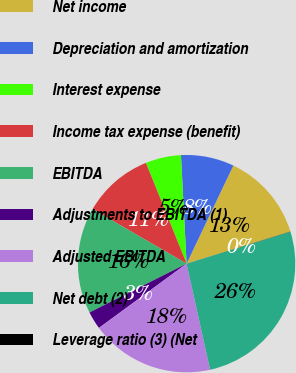Convert chart. <chart><loc_0><loc_0><loc_500><loc_500><pie_chart><fcel>Net income<fcel>Depreciation and amortization<fcel>Interest expense<fcel>Income tax expense (benefit)<fcel>EBITDA<fcel>Adjustments to EBITDA (1)<fcel>Adjusted EBITDA<fcel>Net debt (2)<fcel>Leverage ratio (3) (Net<nl><fcel>13.15%<fcel>7.9%<fcel>5.28%<fcel>10.53%<fcel>15.78%<fcel>2.66%<fcel>18.4%<fcel>26.27%<fcel>0.03%<nl></chart> 